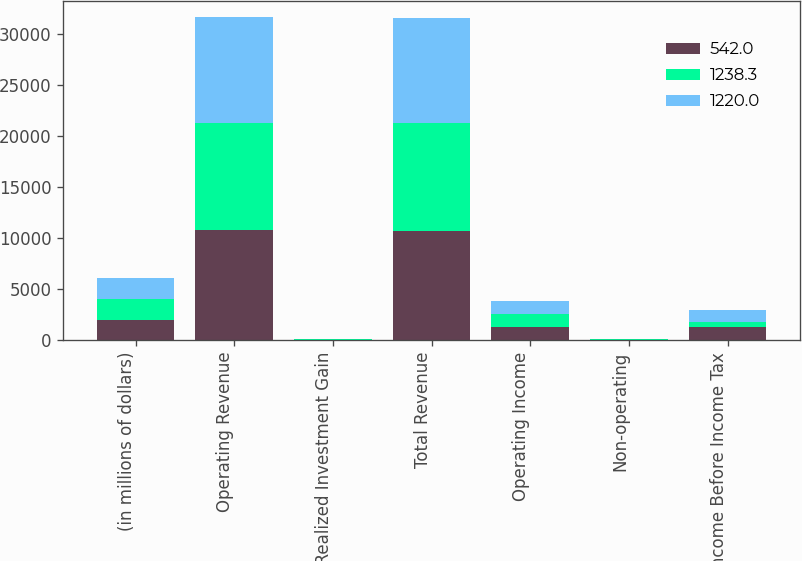Convert chart to OTSL. <chart><loc_0><loc_0><loc_500><loc_500><stacked_bar_chart><ecel><fcel>(in millions of dollars)<fcel>Operating Revenue<fcel>Net Realized Investment Gain<fcel>Total Revenue<fcel>Operating Income<fcel>Non-operating<fcel>Income Before Income Tax<nl><fcel>542<fcel>2015<fcel>10775.1<fcel>43.8<fcel>10731.3<fcel>1294<fcel>11.9<fcel>1238.3<nl><fcel>1238.3<fcel>2014<fcel>10508.4<fcel>16.1<fcel>10524.5<fcel>1307.3<fcel>70<fcel>542<nl><fcel>1220<fcel>2013<fcel>10361.8<fcel>6.8<fcel>10368.6<fcel>1256.6<fcel>32.9<fcel>1220<nl></chart> 